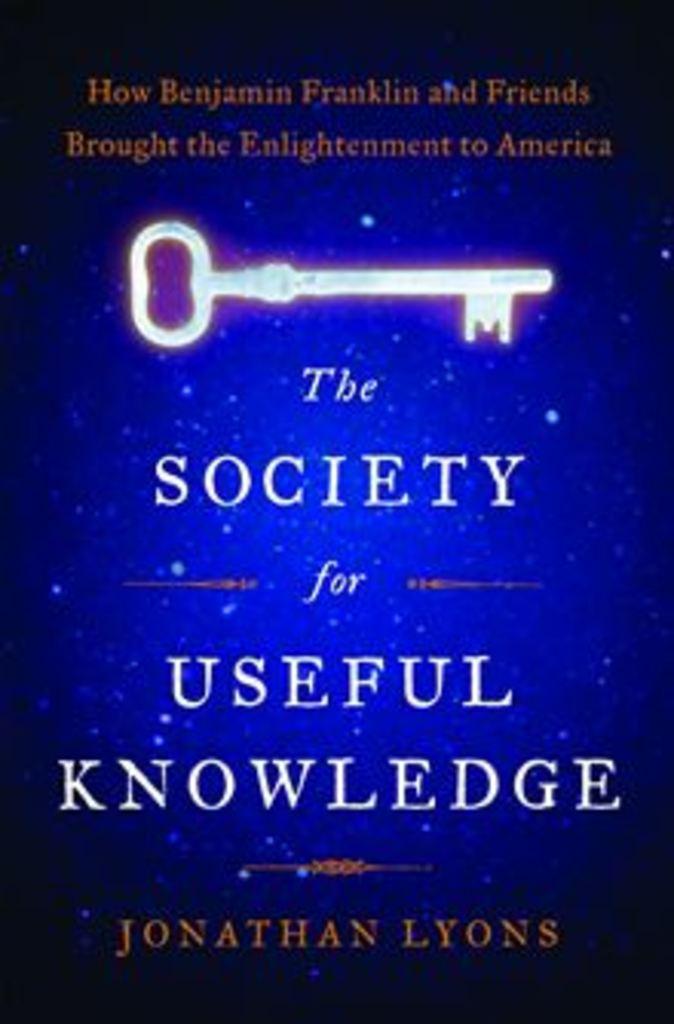Who wrote this book?
Your response must be concise. Jonathan lyons. What is the title of the book?
Ensure brevity in your answer.  The society for useful knowledge. 